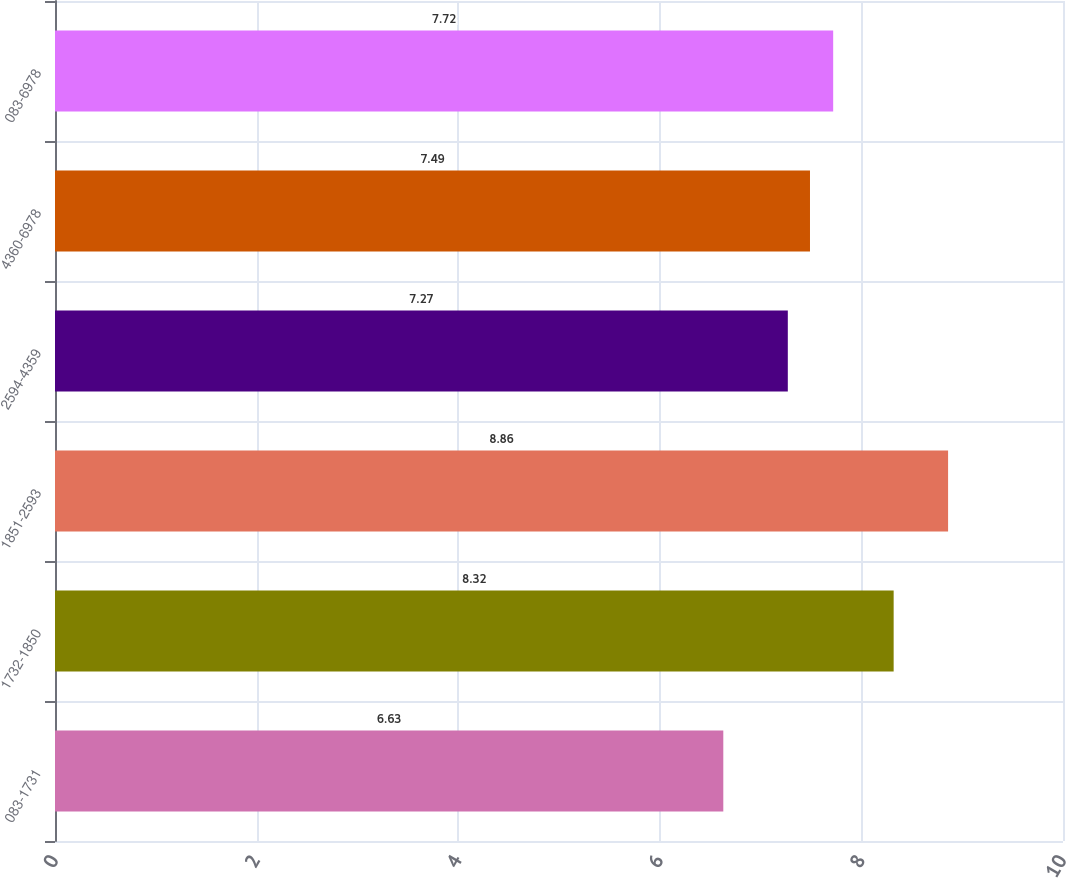Convert chart to OTSL. <chart><loc_0><loc_0><loc_500><loc_500><bar_chart><fcel>083-1731<fcel>1732-1850<fcel>1851-2593<fcel>2594-4359<fcel>4360-6978<fcel>083-6978<nl><fcel>6.63<fcel>8.32<fcel>8.86<fcel>7.27<fcel>7.49<fcel>7.72<nl></chart> 